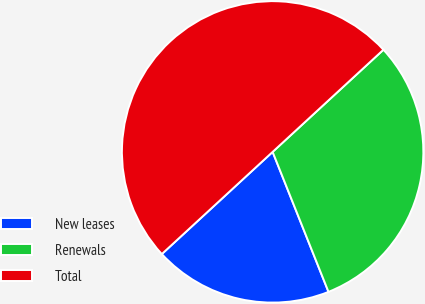<chart> <loc_0><loc_0><loc_500><loc_500><pie_chart><fcel>New leases<fcel>Renewals<fcel>Total<nl><fcel>19.19%<fcel>30.81%<fcel>50.0%<nl></chart> 